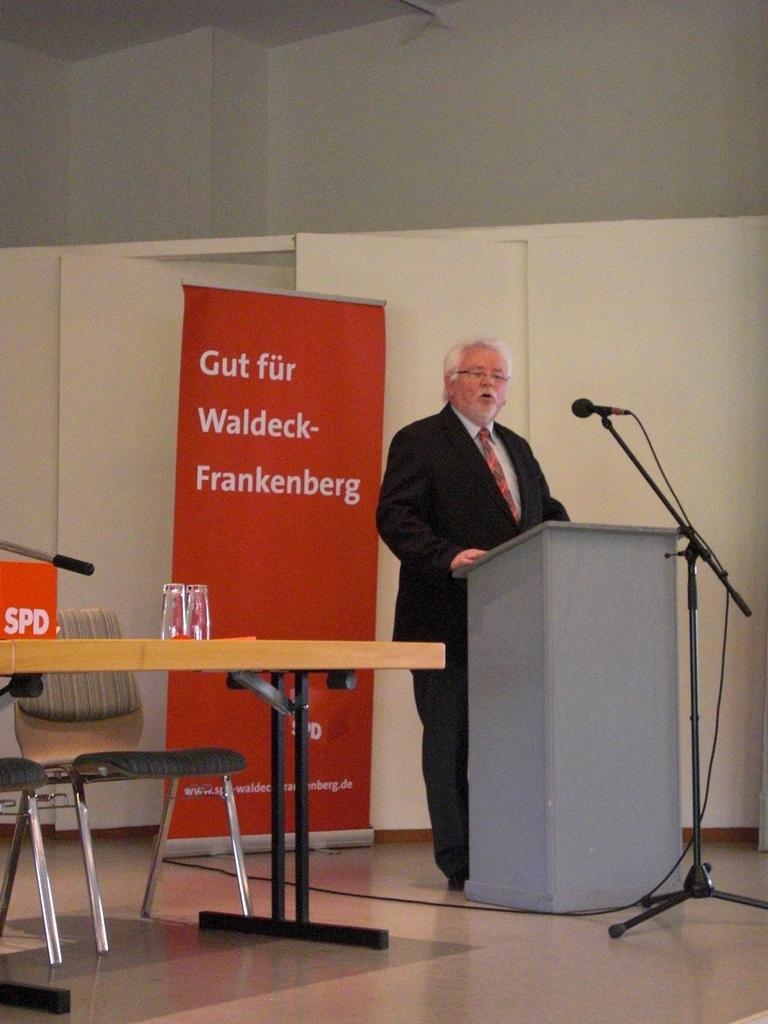Describe this image in one or two sentences. in this image, On the floor there is a table which is in yellow color ,On that table there are glasses kept and a man standing behind a box speaking some thing in microphone and the background there is a wall which is in brown color. 